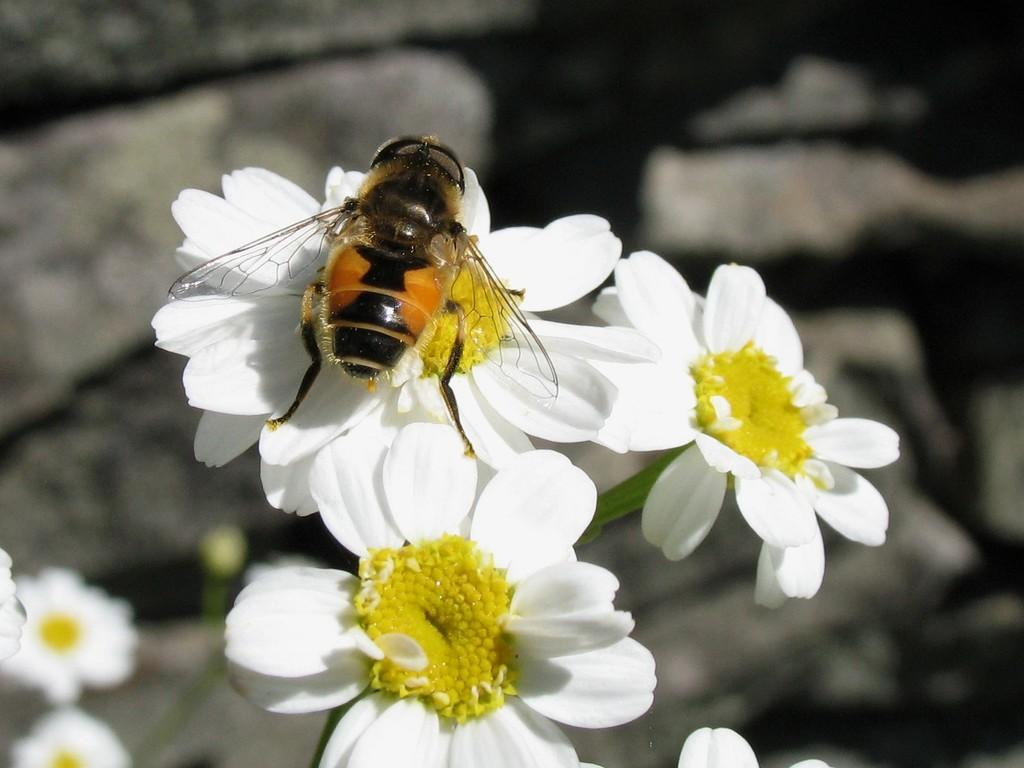What type of flowers can be seen in the image? There are white colored flowers in the image. Is there anything else present on the flowers? Yes, there is an insect on one of the flowers. Can you describe the background of the image? The background of the image is blurred. Can you tell me how much sugar is in the scarecrow's request? There is no scarecrow or sugar present in the image, so it is not possible to answer that question. 